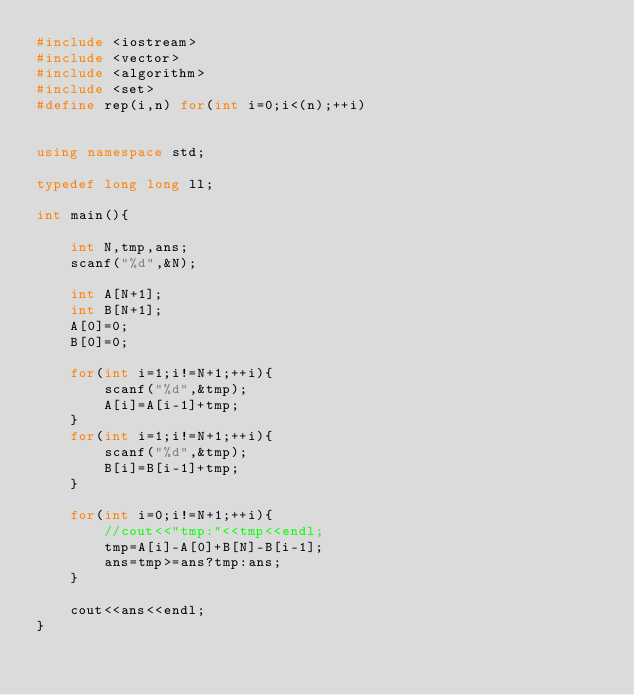<code> <loc_0><loc_0><loc_500><loc_500><_C++_>#include <iostream>
#include <vector>
#include <algorithm>
#include <set>
#define rep(i,n) for(int i=0;i<(n);++i)


using namespace std;

typedef long long ll;

int main(){

    int N,tmp,ans;
    scanf("%d",&N);
    
    int A[N+1];
    int B[N+1];
    A[0]=0;
    B[0]=0;

    for(int i=1;i!=N+1;++i){
        scanf("%d",&tmp);
        A[i]=A[i-1]+tmp;
    }
    for(int i=1;i!=N+1;++i){
        scanf("%d",&tmp);
        B[i]=B[i-1]+tmp;
    }

    for(int i=0;i!=N+1;++i){
        //cout<<"tmp:"<<tmp<<endl;
        tmp=A[i]-A[0]+B[N]-B[i-1];
        ans=tmp>=ans?tmp:ans;
    }

    cout<<ans<<endl;
}</code> 